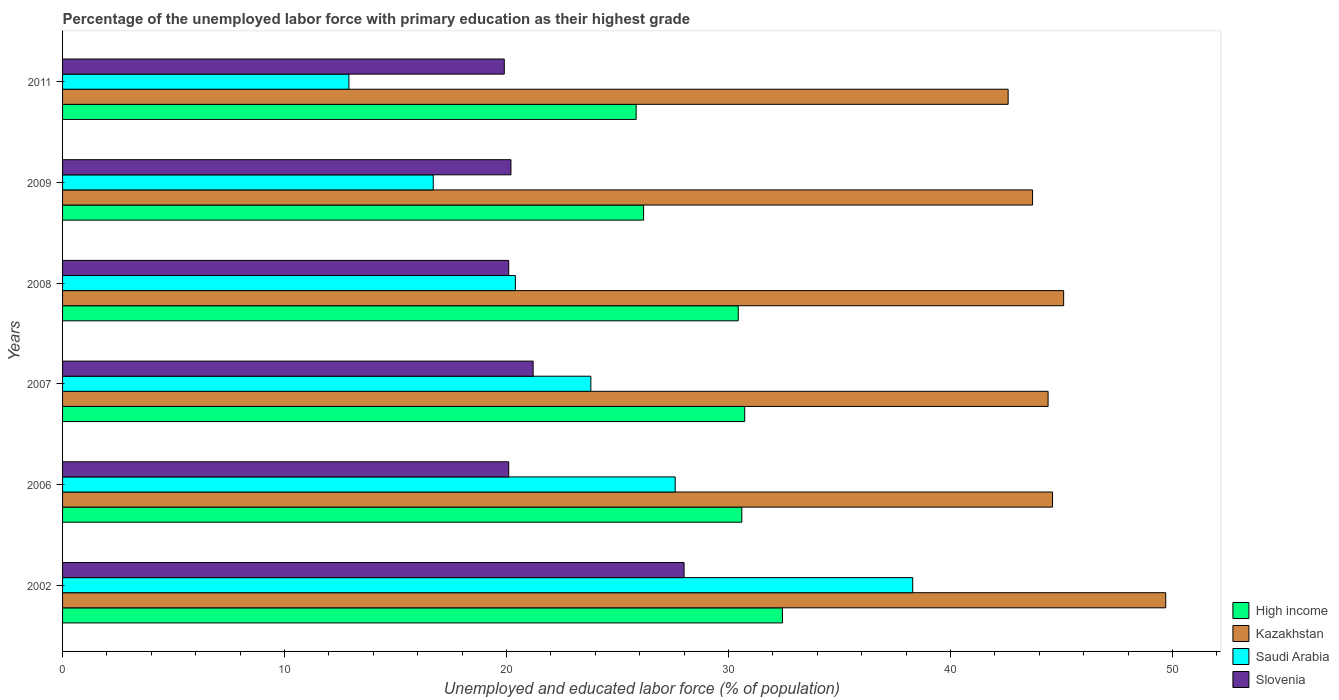How many bars are there on the 6th tick from the top?
Give a very brief answer. 4. How many bars are there on the 3rd tick from the bottom?
Provide a short and direct response. 4. In how many cases, is the number of bars for a given year not equal to the number of legend labels?
Offer a very short reply. 0. What is the percentage of the unemployed labor force with primary education in Kazakhstan in 2009?
Provide a short and direct response. 43.7. Across all years, what is the maximum percentage of the unemployed labor force with primary education in High income?
Offer a very short reply. 32.43. Across all years, what is the minimum percentage of the unemployed labor force with primary education in Slovenia?
Make the answer very short. 19.9. What is the total percentage of the unemployed labor force with primary education in Kazakhstan in the graph?
Your answer should be compact. 270.1. What is the difference between the percentage of the unemployed labor force with primary education in Slovenia in 2002 and that in 2006?
Your answer should be compact. 7.9. What is the difference between the percentage of the unemployed labor force with primary education in Saudi Arabia in 2006 and the percentage of the unemployed labor force with primary education in High income in 2008?
Offer a very short reply. -2.84. What is the average percentage of the unemployed labor force with primary education in High income per year?
Offer a terse response. 29.37. In the year 2007, what is the difference between the percentage of the unemployed labor force with primary education in Kazakhstan and percentage of the unemployed labor force with primary education in High income?
Give a very brief answer. 13.67. In how many years, is the percentage of the unemployed labor force with primary education in Slovenia greater than 36 %?
Keep it short and to the point. 0. What is the ratio of the percentage of the unemployed labor force with primary education in High income in 2002 to that in 2008?
Ensure brevity in your answer.  1.07. Is the percentage of the unemployed labor force with primary education in Kazakhstan in 2007 less than that in 2011?
Provide a short and direct response. No. Is the difference between the percentage of the unemployed labor force with primary education in Kazakhstan in 2002 and 2008 greater than the difference between the percentage of the unemployed labor force with primary education in High income in 2002 and 2008?
Provide a succinct answer. Yes. What is the difference between the highest and the second highest percentage of the unemployed labor force with primary education in Saudi Arabia?
Ensure brevity in your answer.  10.7. What is the difference between the highest and the lowest percentage of the unemployed labor force with primary education in High income?
Offer a very short reply. 6.59. What does the 2nd bar from the top in 2011 represents?
Make the answer very short. Saudi Arabia. What does the 1st bar from the bottom in 2011 represents?
Your response must be concise. High income. How many bars are there?
Ensure brevity in your answer.  24. Are all the bars in the graph horizontal?
Keep it short and to the point. Yes. How many years are there in the graph?
Your response must be concise. 6. Are the values on the major ticks of X-axis written in scientific E-notation?
Offer a very short reply. No. Does the graph contain any zero values?
Your answer should be very brief. No. Where does the legend appear in the graph?
Your response must be concise. Bottom right. How many legend labels are there?
Offer a very short reply. 4. What is the title of the graph?
Make the answer very short. Percentage of the unemployed labor force with primary education as their highest grade. Does "Aruba" appear as one of the legend labels in the graph?
Offer a very short reply. No. What is the label or title of the X-axis?
Make the answer very short. Unemployed and educated labor force (% of population). What is the Unemployed and educated labor force (% of population) in High income in 2002?
Ensure brevity in your answer.  32.43. What is the Unemployed and educated labor force (% of population) of Kazakhstan in 2002?
Make the answer very short. 49.7. What is the Unemployed and educated labor force (% of population) in Saudi Arabia in 2002?
Your answer should be compact. 38.3. What is the Unemployed and educated labor force (% of population) in Slovenia in 2002?
Offer a terse response. 28. What is the Unemployed and educated labor force (% of population) of High income in 2006?
Provide a succinct answer. 30.6. What is the Unemployed and educated labor force (% of population) of Kazakhstan in 2006?
Ensure brevity in your answer.  44.6. What is the Unemployed and educated labor force (% of population) in Saudi Arabia in 2006?
Provide a short and direct response. 27.6. What is the Unemployed and educated labor force (% of population) in Slovenia in 2006?
Keep it short and to the point. 20.1. What is the Unemployed and educated labor force (% of population) of High income in 2007?
Give a very brief answer. 30.73. What is the Unemployed and educated labor force (% of population) of Kazakhstan in 2007?
Offer a very short reply. 44.4. What is the Unemployed and educated labor force (% of population) of Saudi Arabia in 2007?
Your answer should be compact. 23.8. What is the Unemployed and educated labor force (% of population) of Slovenia in 2007?
Offer a very short reply. 21.2. What is the Unemployed and educated labor force (% of population) in High income in 2008?
Offer a very short reply. 30.44. What is the Unemployed and educated labor force (% of population) in Kazakhstan in 2008?
Keep it short and to the point. 45.1. What is the Unemployed and educated labor force (% of population) in Saudi Arabia in 2008?
Your answer should be compact. 20.4. What is the Unemployed and educated labor force (% of population) in Slovenia in 2008?
Your answer should be very brief. 20.1. What is the Unemployed and educated labor force (% of population) of High income in 2009?
Ensure brevity in your answer.  26.18. What is the Unemployed and educated labor force (% of population) of Kazakhstan in 2009?
Make the answer very short. 43.7. What is the Unemployed and educated labor force (% of population) of Saudi Arabia in 2009?
Give a very brief answer. 16.7. What is the Unemployed and educated labor force (% of population) of Slovenia in 2009?
Your answer should be compact. 20.2. What is the Unemployed and educated labor force (% of population) of High income in 2011?
Offer a very short reply. 25.84. What is the Unemployed and educated labor force (% of population) in Kazakhstan in 2011?
Ensure brevity in your answer.  42.6. What is the Unemployed and educated labor force (% of population) in Saudi Arabia in 2011?
Give a very brief answer. 12.9. What is the Unemployed and educated labor force (% of population) in Slovenia in 2011?
Your answer should be very brief. 19.9. Across all years, what is the maximum Unemployed and educated labor force (% of population) of High income?
Offer a terse response. 32.43. Across all years, what is the maximum Unemployed and educated labor force (% of population) in Kazakhstan?
Give a very brief answer. 49.7. Across all years, what is the maximum Unemployed and educated labor force (% of population) of Saudi Arabia?
Provide a succinct answer. 38.3. Across all years, what is the maximum Unemployed and educated labor force (% of population) in Slovenia?
Keep it short and to the point. 28. Across all years, what is the minimum Unemployed and educated labor force (% of population) in High income?
Offer a terse response. 25.84. Across all years, what is the minimum Unemployed and educated labor force (% of population) of Kazakhstan?
Offer a terse response. 42.6. Across all years, what is the minimum Unemployed and educated labor force (% of population) of Saudi Arabia?
Your response must be concise. 12.9. Across all years, what is the minimum Unemployed and educated labor force (% of population) of Slovenia?
Offer a terse response. 19.9. What is the total Unemployed and educated labor force (% of population) of High income in the graph?
Give a very brief answer. 176.22. What is the total Unemployed and educated labor force (% of population) of Kazakhstan in the graph?
Make the answer very short. 270.1. What is the total Unemployed and educated labor force (% of population) of Saudi Arabia in the graph?
Provide a succinct answer. 139.7. What is the total Unemployed and educated labor force (% of population) of Slovenia in the graph?
Provide a short and direct response. 129.5. What is the difference between the Unemployed and educated labor force (% of population) of High income in 2002 and that in 2006?
Offer a very short reply. 1.83. What is the difference between the Unemployed and educated labor force (% of population) in Kazakhstan in 2002 and that in 2006?
Offer a very short reply. 5.1. What is the difference between the Unemployed and educated labor force (% of population) in Slovenia in 2002 and that in 2006?
Your response must be concise. 7.9. What is the difference between the Unemployed and educated labor force (% of population) of Kazakhstan in 2002 and that in 2007?
Keep it short and to the point. 5.3. What is the difference between the Unemployed and educated labor force (% of population) in Slovenia in 2002 and that in 2007?
Provide a short and direct response. 6.8. What is the difference between the Unemployed and educated labor force (% of population) of High income in 2002 and that in 2008?
Keep it short and to the point. 1.99. What is the difference between the Unemployed and educated labor force (% of population) of High income in 2002 and that in 2009?
Offer a terse response. 6.25. What is the difference between the Unemployed and educated labor force (% of population) in Kazakhstan in 2002 and that in 2009?
Offer a very short reply. 6. What is the difference between the Unemployed and educated labor force (% of population) of Saudi Arabia in 2002 and that in 2009?
Ensure brevity in your answer.  21.6. What is the difference between the Unemployed and educated labor force (% of population) of Slovenia in 2002 and that in 2009?
Your answer should be very brief. 7.8. What is the difference between the Unemployed and educated labor force (% of population) in High income in 2002 and that in 2011?
Make the answer very short. 6.59. What is the difference between the Unemployed and educated labor force (% of population) in Saudi Arabia in 2002 and that in 2011?
Provide a short and direct response. 25.4. What is the difference between the Unemployed and educated labor force (% of population) of Slovenia in 2002 and that in 2011?
Offer a terse response. 8.1. What is the difference between the Unemployed and educated labor force (% of population) in High income in 2006 and that in 2007?
Your answer should be very brief. -0.13. What is the difference between the Unemployed and educated labor force (% of population) in Saudi Arabia in 2006 and that in 2007?
Offer a terse response. 3.8. What is the difference between the Unemployed and educated labor force (% of population) of Slovenia in 2006 and that in 2007?
Ensure brevity in your answer.  -1.1. What is the difference between the Unemployed and educated labor force (% of population) in High income in 2006 and that in 2008?
Your answer should be compact. 0.16. What is the difference between the Unemployed and educated labor force (% of population) of Kazakhstan in 2006 and that in 2008?
Offer a terse response. -0.5. What is the difference between the Unemployed and educated labor force (% of population) of Saudi Arabia in 2006 and that in 2008?
Your answer should be compact. 7.2. What is the difference between the Unemployed and educated labor force (% of population) in High income in 2006 and that in 2009?
Your answer should be very brief. 4.43. What is the difference between the Unemployed and educated labor force (% of population) in Kazakhstan in 2006 and that in 2009?
Give a very brief answer. 0.9. What is the difference between the Unemployed and educated labor force (% of population) in Saudi Arabia in 2006 and that in 2009?
Your response must be concise. 10.9. What is the difference between the Unemployed and educated labor force (% of population) in High income in 2006 and that in 2011?
Provide a short and direct response. 4.76. What is the difference between the Unemployed and educated labor force (% of population) in Kazakhstan in 2006 and that in 2011?
Give a very brief answer. 2. What is the difference between the Unemployed and educated labor force (% of population) in High income in 2007 and that in 2008?
Ensure brevity in your answer.  0.29. What is the difference between the Unemployed and educated labor force (% of population) in Saudi Arabia in 2007 and that in 2008?
Ensure brevity in your answer.  3.4. What is the difference between the Unemployed and educated labor force (% of population) in Slovenia in 2007 and that in 2008?
Your answer should be compact. 1.1. What is the difference between the Unemployed and educated labor force (% of population) in High income in 2007 and that in 2009?
Offer a very short reply. 4.55. What is the difference between the Unemployed and educated labor force (% of population) of Saudi Arabia in 2007 and that in 2009?
Your response must be concise. 7.1. What is the difference between the Unemployed and educated labor force (% of population) of High income in 2007 and that in 2011?
Your answer should be compact. 4.89. What is the difference between the Unemployed and educated labor force (% of population) in Saudi Arabia in 2007 and that in 2011?
Your answer should be compact. 10.9. What is the difference between the Unemployed and educated labor force (% of population) of High income in 2008 and that in 2009?
Offer a terse response. 4.26. What is the difference between the Unemployed and educated labor force (% of population) of Saudi Arabia in 2008 and that in 2009?
Your answer should be compact. 3.7. What is the difference between the Unemployed and educated labor force (% of population) of Slovenia in 2008 and that in 2009?
Ensure brevity in your answer.  -0.1. What is the difference between the Unemployed and educated labor force (% of population) in High income in 2008 and that in 2011?
Keep it short and to the point. 4.6. What is the difference between the Unemployed and educated labor force (% of population) in Saudi Arabia in 2008 and that in 2011?
Your response must be concise. 7.5. What is the difference between the Unemployed and educated labor force (% of population) in Slovenia in 2008 and that in 2011?
Your answer should be very brief. 0.2. What is the difference between the Unemployed and educated labor force (% of population) in High income in 2009 and that in 2011?
Your response must be concise. 0.33. What is the difference between the Unemployed and educated labor force (% of population) in Kazakhstan in 2009 and that in 2011?
Make the answer very short. 1.1. What is the difference between the Unemployed and educated labor force (% of population) of Saudi Arabia in 2009 and that in 2011?
Provide a short and direct response. 3.8. What is the difference between the Unemployed and educated labor force (% of population) of Slovenia in 2009 and that in 2011?
Offer a terse response. 0.3. What is the difference between the Unemployed and educated labor force (% of population) of High income in 2002 and the Unemployed and educated labor force (% of population) of Kazakhstan in 2006?
Offer a terse response. -12.17. What is the difference between the Unemployed and educated labor force (% of population) in High income in 2002 and the Unemployed and educated labor force (% of population) in Saudi Arabia in 2006?
Keep it short and to the point. 4.83. What is the difference between the Unemployed and educated labor force (% of population) of High income in 2002 and the Unemployed and educated labor force (% of population) of Slovenia in 2006?
Provide a succinct answer. 12.33. What is the difference between the Unemployed and educated labor force (% of population) in Kazakhstan in 2002 and the Unemployed and educated labor force (% of population) in Saudi Arabia in 2006?
Offer a very short reply. 22.1. What is the difference between the Unemployed and educated labor force (% of population) in Kazakhstan in 2002 and the Unemployed and educated labor force (% of population) in Slovenia in 2006?
Offer a very short reply. 29.6. What is the difference between the Unemployed and educated labor force (% of population) of Saudi Arabia in 2002 and the Unemployed and educated labor force (% of population) of Slovenia in 2006?
Your answer should be very brief. 18.2. What is the difference between the Unemployed and educated labor force (% of population) of High income in 2002 and the Unemployed and educated labor force (% of population) of Kazakhstan in 2007?
Keep it short and to the point. -11.97. What is the difference between the Unemployed and educated labor force (% of population) of High income in 2002 and the Unemployed and educated labor force (% of population) of Saudi Arabia in 2007?
Provide a succinct answer. 8.63. What is the difference between the Unemployed and educated labor force (% of population) in High income in 2002 and the Unemployed and educated labor force (% of population) in Slovenia in 2007?
Give a very brief answer. 11.23. What is the difference between the Unemployed and educated labor force (% of population) of Kazakhstan in 2002 and the Unemployed and educated labor force (% of population) of Saudi Arabia in 2007?
Provide a short and direct response. 25.9. What is the difference between the Unemployed and educated labor force (% of population) in Kazakhstan in 2002 and the Unemployed and educated labor force (% of population) in Slovenia in 2007?
Provide a short and direct response. 28.5. What is the difference between the Unemployed and educated labor force (% of population) of Saudi Arabia in 2002 and the Unemployed and educated labor force (% of population) of Slovenia in 2007?
Make the answer very short. 17.1. What is the difference between the Unemployed and educated labor force (% of population) in High income in 2002 and the Unemployed and educated labor force (% of population) in Kazakhstan in 2008?
Offer a terse response. -12.67. What is the difference between the Unemployed and educated labor force (% of population) in High income in 2002 and the Unemployed and educated labor force (% of population) in Saudi Arabia in 2008?
Offer a terse response. 12.03. What is the difference between the Unemployed and educated labor force (% of population) of High income in 2002 and the Unemployed and educated labor force (% of population) of Slovenia in 2008?
Provide a succinct answer. 12.33. What is the difference between the Unemployed and educated labor force (% of population) of Kazakhstan in 2002 and the Unemployed and educated labor force (% of population) of Saudi Arabia in 2008?
Give a very brief answer. 29.3. What is the difference between the Unemployed and educated labor force (% of population) in Kazakhstan in 2002 and the Unemployed and educated labor force (% of population) in Slovenia in 2008?
Provide a succinct answer. 29.6. What is the difference between the Unemployed and educated labor force (% of population) of Saudi Arabia in 2002 and the Unemployed and educated labor force (% of population) of Slovenia in 2008?
Offer a terse response. 18.2. What is the difference between the Unemployed and educated labor force (% of population) in High income in 2002 and the Unemployed and educated labor force (% of population) in Kazakhstan in 2009?
Your answer should be very brief. -11.27. What is the difference between the Unemployed and educated labor force (% of population) in High income in 2002 and the Unemployed and educated labor force (% of population) in Saudi Arabia in 2009?
Provide a succinct answer. 15.73. What is the difference between the Unemployed and educated labor force (% of population) of High income in 2002 and the Unemployed and educated labor force (% of population) of Slovenia in 2009?
Offer a very short reply. 12.23. What is the difference between the Unemployed and educated labor force (% of population) of Kazakhstan in 2002 and the Unemployed and educated labor force (% of population) of Slovenia in 2009?
Provide a succinct answer. 29.5. What is the difference between the Unemployed and educated labor force (% of population) in Saudi Arabia in 2002 and the Unemployed and educated labor force (% of population) in Slovenia in 2009?
Offer a very short reply. 18.1. What is the difference between the Unemployed and educated labor force (% of population) of High income in 2002 and the Unemployed and educated labor force (% of population) of Kazakhstan in 2011?
Keep it short and to the point. -10.17. What is the difference between the Unemployed and educated labor force (% of population) in High income in 2002 and the Unemployed and educated labor force (% of population) in Saudi Arabia in 2011?
Your response must be concise. 19.53. What is the difference between the Unemployed and educated labor force (% of population) in High income in 2002 and the Unemployed and educated labor force (% of population) in Slovenia in 2011?
Offer a very short reply. 12.53. What is the difference between the Unemployed and educated labor force (% of population) in Kazakhstan in 2002 and the Unemployed and educated labor force (% of population) in Saudi Arabia in 2011?
Make the answer very short. 36.8. What is the difference between the Unemployed and educated labor force (% of population) of Kazakhstan in 2002 and the Unemployed and educated labor force (% of population) of Slovenia in 2011?
Your response must be concise. 29.8. What is the difference between the Unemployed and educated labor force (% of population) in High income in 2006 and the Unemployed and educated labor force (% of population) in Kazakhstan in 2007?
Make the answer very short. -13.8. What is the difference between the Unemployed and educated labor force (% of population) in High income in 2006 and the Unemployed and educated labor force (% of population) in Saudi Arabia in 2007?
Keep it short and to the point. 6.8. What is the difference between the Unemployed and educated labor force (% of population) of High income in 2006 and the Unemployed and educated labor force (% of population) of Slovenia in 2007?
Your answer should be compact. 9.4. What is the difference between the Unemployed and educated labor force (% of population) in Kazakhstan in 2006 and the Unemployed and educated labor force (% of population) in Saudi Arabia in 2007?
Provide a short and direct response. 20.8. What is the difference between the Unemployed and educated labor force (% of population) of Kazakhstan in 2006 and the Unemployed and educated labor force (% of population) of Slovenia in 2007?
Provide a succinct answer. 23.4. What is the difference between the Unemployed and educated labor force (% of population) of High income in 2006 and the Unemployed and educated labor force (% of population) of Kazakhstan in 2008?
Provide a succinct answer. -14.5. What is the difference between the Unemployed and educated labor force (% of population) of High income in 2006 and the Unemployed and educated labor force (% of population) of Saudi Arabia in 2008?
Your response must be concise. 10.2. What is the difference between the Unemployed and educated labor force (% of population) in High income in 2006 and the Unemployed and educated labor force (% of population) in Slovenia in 2008?
Ensure brevity in your answer.  10.5. What is the difference between the Unemployed and educated labor force (% of population) in Kazakhstan in 2006 and the Unemployed and educated labor force (% of population) in Saudi Arabia in 2008?
Your answer should be very brief. 24.2. What is the difference between the Unemployed and educated labor force (% of population) of Saudi Arabia in 2006 and the Unemployed and educated labor force (% of population) of Slovenia in 2008?
Keep it short and to the point. 7.5. What is the difference between the Unemployed and educated labor force (% of population) in High income in 2006 and the Unemployed and educated labor force (% of population) in Kazakhstan in 2009?
Offer a very short reply. -13.1. What is the difference between the Unemployed and educated labor force (% of population) of High income in 2006 and the Unemployed and educated labor force (% of population) of Saudi Arabia in 2009?
Offer a very short reply. 13.9. What is the difference between the Unemployed and educated labor force (% of population) in High income in 2006 and the Unemployed and educated labor force (% of population) in Slovenia in 2009?
Provide a succinct answer. 10.4. What is the difference between the Unemployed and educated labor force (% of population) of Kazakhstan in 2006 and the Unemployed and educated labor force (% of population) of Saudi Arabia in 2009?
Ensure brevity in your answer.  27.9. What is the difference between the Unemployed and educated labor force (% of population) of Kazakhstan in 2006 and the Unemployed and educated labor force (% of population) of Slovenia in 2009?
Give a very brief answer. 24.4. What is the difference between the Unemployed and educated labor force (% of population) of Saudi Arabia in 2006 and the Unemployed and educated labor force (% of population) of Slovenia in 2009?
Your response must be concise. 7.4. What is the difference between the Unemployed and educated labor force (% of population) in High income in 2006 and the Unemployed and educated labor force (% of population) in Kazakhstan in 2011?
Offer a very short reply. -12. What is the difference between the Unemployed and educated labor force (% of population) of High income in 2006 and the Unemployed and educated labor force (% of population) of Saudi Arabia in 2011?
Offer a terse response. 17.7. What is the difference between the Unemployed and educated labor force (% of population) in High income in 2006 and the Unemployed and educated labor force (% of population) in Slovenia in 2011?
Offer a very short reply. 10.7. What is the difference between the Unemployed and educated labor force (% of population) in Kazakhstan in 2006 and the Unemployed and educated labor force (% of population) in Saudi Arabia in 2011?
Provide a short and direct response. 31.7. What is the difference between the Unemployed and educated labor force (% of population) in Kazakhstan in 2006 and the Unemployed and educated labor force (% of population) in Slovenia in 2011?
Offer a terse response. 24.7. What is the difference between the Unemployed and educated labor force (% of population) in Saudi Arabia in 2006 and the Unemployed and educated labor force (% of population) in Slovenia in 2011?
Keep it short and to the point. 7.7. What is the difference between the Unemployed and educated labor force (% of population) in High income in 2007 and the Unemployed and educated labor force (% of population) in Kazakhstan in 2008?
Give a very brief answer. -14.37. What is the difference between the Unemployed and educated labor force (% of population) of High income in 2007 and the Unemployed and educated labor force (% of population) of Saudi Arabia in 2008?
Offer a terse response. 10.33. What is the difference between the Unemployed and educated labor force (% of population) in High income in 2007 and the Unemployed and educated labor force (% of population) in Slovenia in 2008?
Keep it short and to the point. 10.63. What is the difference between the Unemployed and educated labor force (% of population) in Kazakhstan in 2007 and the Unemployed and educated labor force (% of population) in Slovenia in 2008?
Provide a succinct answer. 24.3. What is the difference between the Unemployed and educated labor force (% of population) of Saudi Arabia in 2007 and the Unemployed and educated labor force (% of population) of Slovenia in 2008?
Your response must be concise. 3.7. What is the difference between the Unemployed and educated labor force (% of population) in High income in 2007 and the Unemployed and educated labor force (% of population) in Kazakhstan in 2009?
Keep it short and to the point. -12.97. What is the difference between the Unemployed and educated labor force (% of population) of High income in 2007 and the Unemployed and educated labor force (% of population) of Saudi Arabia in 2009?
Offer a very short reply. 14.03. What is the difference between the Unemployed and educated labor force (% of population) of High income in 2007 and the Unemployed and educated labor force (% of population) of Slovenia in 2009?
Offer a terse response. 10.53. What is the difference between the Unemployed and educated labor force (% of population) of Kazakhstan in 2007 and the Unemployed and educated labor force (% of population) of Saudi Arabia in 2009?
Give a very brief answer. 27.7. What is the difference between the Unemployed and educated labor force (% of population) of Kazakhstan in 2007 and the Unemployed and educated labor force (% of population) of Slovenia in 2009?
Provide a succinct answer. 24.2. What is the difference between the Unemployed and educated labor force (% of population) in Saudi Arabia in 2007 and the Unemployed and educated labor force (% of population) in Slovenia in 2009?
Offer a very short reply. 3.6. What is the difference between the Unemployed and educated labor force (% of population) in High income in 2007 and the Unemployed and educated labor force (% of population) in Kazakhstan in 2011?
Keep it short and to the point. -11.87. What is the difference between the Unemployed and educated labor force (% of population) of High income in 2007 and the Unemployed and educated labor force (% of population) of Saudi Arabia in 2011?
Ensure brevity in your answer.  17.83. What is the difference between the Unemployed and educated labor force (% of population) of High income in 2007 and the Unemployed and educated labor force (% of population) of Slovenia in 2011?
Your answer should be compact. 10.83. What is the difference between the Unemployed and educated labor force (% of population) in Kazakhstan in 2007 and the Unemployed and educated labor force (% of population) in Saudi Arabia in 2011?
Your response must be concise. 31.5. What is the difference between the Unemployed and educated labor force (% of population) in High income in 2008 and the Unemployed and educated labor force (% of population) in Kazakhstan in 2009?
Your answer should be very brief. -13.26. What is the difference between the Unemployed and educated labor force (% of population) in High income in 2008 and the Unemployed and educated labor force (% of population) in Saudi Arabia in 2009?
Your answer should be compact. 13.74. What is the difference between the Unemployed and educated labor force (% of population) of High income in 2008 and the Unemployed and educated labor force (% of population) of Slovenia in 2009?
Your response must be concise. 10.24. What is the difference between the Unemployed and educated labor force (% of population) of Kazakhstan in 2008 and the Unemployed and educated labor force (% of population) of Saudi Arabia in 2009?
Ensure brevity in your answer.  28.4. What is the difference between the Unemployed and educated labor force (% of population) in Kazakhstan in 2008 and the Unemployed and educated labor force (% of population) in Slovenia in 2009?
Provide a succinct answer. 24.9. What is the difference between the Unemployed and educated labor force (% of population) of High income in 2008 and the Unemployed and educated labor force (% of population) of Kazakhstan in 2011?
Provide a succinct answer. -12.16. What is the difference between the Unemployed and educated labor force (% of population) of High income in 2008 and the Unemployed and educated labor force (% of population) of Saudi Arabia in 2011?
Provide a short and direct response. 17.54. What is the difference between the Unemployed and educated labor force (% of population) of High income in 2008 and the Unemployed and educated labor force (% of population) of Slovenia in 2011?
Your answer should be very brief. 10.54. What is the difference between the Unemployed and educated labor force (% of population) in Kazakhstan in 2008 and the Unemployed and educated labor force (% of population) in Saudi Arabia in 2011?
Provide a succinct answer. 32.2. What is the difference between the Unemployed and educated labor force (% of population) in Kazakhstan in 2008 and the Unemployed and educated labor force (% of population) in Slovenia in 2011?
Provide a short and direct response. 25.2. What is the difference between the Unemployed and educated labor force (% of population) in High income in 2009 and the Unemployed and educated labor force (% of population) in Kazakhstan in 2011?
Your answer should be compact. -16.42. What is the difference between the Unemployed and educated labor force (% of population) of High income in 2009 and the Unemployed and educated labor force (% of population) of Saudi Arabia in 2011?
Provide a succinct answer. 13.28. What is the difference between the Unemployed and educated labor force (% of population) in High income in 2009 and the Unemployed and educated labor force (% of population) in Slovenia in 2011?
Ensure brevity in your answer.  6.28. What is the difference between the Unemployed and educated labor force (% of population) of Kazakhstan in 2009 and the Unemployed and educated labor force (% of population) of Saudi Arabia in 2011?
Your answer should be very brief. 30.8. What is the difference between the Unemployed and educated labor force (% of population) of Kazakhstan in 2009 and the Unemployed and educated labor force (% of population) of Slovenia in 2011?
Your answer should be very brief. 23.8. What is the average Unemployed and educated labor force (% of population) of High income per year?
Your response must be concise. 29.37. What is the average Unemployed and educated labor force (% of population) of Kazakhstan per year?
Your answer should be compact. 45.02. What is the average Unemployed and educated labor force (% of population) of Saudi Arabia per year?
Your answer should be compact. 23.28. What is the average Unemployed and educated labor force (% of population) of Slovenia per year?
Make the answer very short. 21.58. In the year 2002, what is the difference between the Unemployed and educated labor force (% of population) in High income and Unemployed and educated labor force (% of population) in Kazakhstan?
Keep it short and to the point. -17.27. In the year 2002, what is the difference between the Unemployed and educated labor force (% of population) in High income and Unemployed and educated labor force (% of population) in Saudi Arabia?
Provide a short and direct response. -5.87. In the year 2002, what is the difference between the Unemployed and educated labor force (% of population) of High income and Unemployed and educated labor force (% of population) of Slovenia?
Make the answer very short. 4.43. In the year 2002, what is the difference between the Unemployed and educated labor force (% of population) in Kazakhstan and Unemployed and educated labor force (% of population) in Saudi Arabia?
Provide a short and direct response. 11.4. In the year 2002, what is the difference between the Unemployed and educated labor force (% of population) in Kazakhstan and Unemployed and educated labor force (% of population) in Slovenia?
Give a very brief answer. 21.7. In the year 2006, what is the difference between the Unemployed and educated labor force (% of population) of High income and Unemployed and educated labor force (% of population) of Kazakhstan?
Keep it short and to the point. -14. In the year 2006, what is the difference between the Unemployed and educated labor force (% of population) in High income and Unemployed and educated labor force (% of population) in Saudi Arabia?
Provide a short and direct response. 3. In the year 2006, what is the difference between the Unemployed and educated labor force (% of population) in High income and Unemployed and educated labor force (% of population) in Slovenia?
Give a very brief answer. 10.5. In the year 2006, what is the difference between the Unemployed and educated labor force (% of population) of Kazakhstan and Unemployed and educated labor force (% of population) of Saudi Arabia?
Your answer should be very brief. 17. In the year 2006, what is the difference between the Unemployed and educated labor force (% of population) in Kazakhstan and Unemployed and educated labor force (% of population) in Slovenia?
Your response must be concise. 24.5. In the year 2006, what is the difference between the Unemployed and educated labor force (% of population) in Saudi Arabia and Unemployed and educated labor force (% of population) in Slovenia?
Make the answer very short. 7.5. In the year 2007, what is the difference between the Unemployed and educated labor force (% of population) of High income and Unemployed and educated labor force (% of population) of Kazakhstan?
Ensure brevity in your answer.  -13.67. In the year 2007, what is the difference between the Unemployed and educated labor force (% of population) in High income and Unemployed and educated labor force (% of population) in Saudi Arabia?
Give a very brief answer. 6.93. In the year 2007, what is the difference between the Unemployed and educated labor force (% of population) of High income and Unemployed and educated labor force (% of population) of Slovenia?
Provide a short and direct response. 9.53. In the year 2007, what is the difference between the Unemployed and educated labor force (% of population) in Kazakhstan and Unemployed and educated labor force (% of population) in Saudi Arabia?
Your answer should be very brief. 20.6. In the year 2007, what is the difference between the Unemployed and educated labor force (% of population) in Kazakhstan and Unemployed and educated labor force (% of population) in Slovenia?
Your answer should be very brief. 23.2. In the year 2008, what is the difference between the Unemployed and educated labor force (% of population) in High income and Unemployed and educated labor force (% of population) in Kazakhstan?
Give a very brief answer. -14.66. In the year 2008, what is the difference between the Unemployed and educated labor force (% of population) in High income and Unemployed and educated labor force (% of population) in Saudi Arabia?
Offer a very short reply. 10.04. In the year 2008, what is the difference between the Unemployed and educated labor force (% of population) of High income and Unemployed and educated labor force (% of population) of Slovenia?
Keep it short and to the point. 10.34. In the year 2008, what is the difference between the Unemployed and educated labor force (% of population) in Kazakhstan and Unemployed and educated labor force (% of population) in Saudi Arabia?
Offer a terse response. 24.7. In the year 2008, what is the difference between the Unemployed and educated labor force (% of population) in Kazakhstan and Unemployed and educated labor force (% of population) in Slovenia?
Keep it short and to the point. 25. In the year 2008, what is the difference between the Unemployed and educated labor force (% of population) in Saudi Arabia and Unemployed and educated labor force (% of population) in Slovenia?
Give a very brief answer. 0.3. In the year 2009, what is the difference between the Unemployed and educated labor force (% of population) in High income and Unemployed and educated labor force (% of population) in Kazakhstan?
Your response must be concise. -17.52. In the year 2009, what is the difference between the Unemployed and educated labor force (% of population) of High income and Unemployed and educated labor force (% of population) of Saudi Arabia?
Provide a succinct answer. 9.48. In the year 2009, what is the difference between the Unemployed and educated labor force (% of population) in High income and Unemployed and educated labor force (% of population) in Slovenia?
Keep it short and to the point. 5.98. In the year 2009, what is the difference between the Unemployed and educated labor force (% of population) in Saudi Arabia and Unemployed and educated labor force (% of population) in Slovenia?
Offer a very short reply. -3.5. In the year 2011, what is the difference between the Unemployed and educated labor force (% of population) of High income and Unemployed and educated labor force (% of population) of Kazakhstan?
Your response must be concise. -16.76. In the year 2011, what is the difference between the Unemployed and educated labor force (% of population) of High income and Unemployed and educated labor force (% of population) of Saudi Arabia?
Keep it short and to the point. 12.94. In the year 2011, what is the difference between the Unemployed and educated labor force (% of population) of High income and Unemployed and educated labor force (% of population) of Slovenia?
Offer a very short reply. 5.94. In the year 2011, what is the difference between the Unemployed and educated labor force (% of population) of Kazakhstan and Unemployed and educated labor force (% of population) of Saudi Arabia?
Your answer should be very brief. 29.7. In the year 2011, what is the difference between the Unemployed and educated labor force (% of population) in Kazakhstan and Unemployed and educated labor force (% of population) in Slovenia?
Provide a short and direct response. 22.7. In the year 2011, what is the difference between the Unemployed and educated labor force (% of population) of Saudi Arabia and Unemployed and educated labor force (% of population) of Slovenia?
Your answer should be compact. -7. What is the ratio of the Unemployed and educated labor force (% of population) in High income in 2002 to that in 2006?
Ensure brevity in your answer.  1.06. What is the ratio of the Unemployed and educated labor force (% of population) of Kazakhstan in 2002 to that in 2006?
Provide a short and direct response. 1.11. What is the ratio of the Unemployed and educated labor force (% of population) in Saudi Arabia in 2002 to that in 2006?
Provide a short and direct response. 1.39. What is the ratio of the Unemployed and educated labor force (% of population) of Slovenia in 2002 to that in 2006?
Your answer should be compact. 1.39. What is the ratio of the Unemployed and educated labor force (% of population) of High income in 2002 to that in 2007?
Ensure brevity in your answer.  1.06. What is the ratio of the Unemployed and educated labor force (% of population) of Kazakhstan in 2002 to that in 2007?
Provide a short and direct response. 1.12. What is the ratio of the Unemployed and educated labor force (% of population) in Saudi Arabia in 2002 to that in 2007?
Your response must be concise. 1.61. What is the ratio of the Unemployed and educated labor force (% of population) of Slovenia in 2002 to that in 2007?
Keep it short and to the point. 1.32. What is the ratio of the Unemployed and educated labor force (% of population) in High income in 2002 to that in 2008?
Provide a succinct answer. 1.07. What is the ratio of the Unemployed and educated labor force (% of population) of Kazakhstan in 2002 to that in 2008?
Provide a short and direct response. 1.1. What is the ratio of the Unemployed and educated labor force (% of population) in Saudi Arabia in 2002 to that in 2008?
Provide a short and direct response. 1.88. What is the ratio of the Unemployed and educated labor force (% of population) of Slovenia in 2002 to that in 2008?
Keep it short and to the point. 1.39. What is the ratio of the Unemployed and educated labor force (% of population) in High income in 2002 to that in 2009?
Offer a very short reply. 1.24. What is the ratio of the Unemployed and educated labor force (% of population) in Kazakhstan in 2002 to that in 2009?
Your answer should be compact. 1.14. What is the ratio of the Unemployed and educated labor force (% of population) of Saudi Arabia in 2002 to that in 2009?
Provide a short and direct response. 2.29. What is the ratio of the Unemployed and educated labor force (% of population) in Slovenia in 2002 to that in 2009?
Your answer should be very brief. 1.39. What is the ratio of the Unemployed and educated labor force (% of population) of High income in 2002 to that in 2011?
Your response must be concise. 1.25. What is the ratio of the Unemployed and educated labor force (% of population) in Kazakhstan in 2002 to that in 2011?
Provide a succinct answer. 1.17. What is the ratio of the Unemployed and educated labor force (% of population) of Saudi Arabia in 2002 to that in 2011?
Provide a short and direct response. 2.97. What is the ratio of the Unemployed and educated labor force (% of population) of Slovenia in 2002 to that in 2011?
Ensure brevity in your answer.  1.41. What is the ratio of the Unemployed and educated labor force (% of population) of Kazakhstan in 2006 to that in 2007?
Provide a short and direct response. 1. What is the ratio of the Unemployed and educated labor force (% of population) in Saudi Arabia in 2006 to that in 2007?
Your answer should be very brief. 1.16. What is the ratio of the Unemployed and educated labor force (% of population) in Slovenia in 2006 to that in 2007?
Provide a short and direct response. 0.95. What is the ratio of the Unemployed and educated labor force (% of population) of High income in 2006 to that in 2008?
Your answer should be very brief. 1.01. What is the ratio of the Unemployed and educated labor force (% of population) of Kazakhstan in 2006 to that in 2008?
Make the answer very short. 0.99. What is the ratio of the Unemployed and educated labor force (% of population) of Saudi Arabia in 2006 to that in 2008?
Keep it short and to the point. 1.35. What is the ratio of the Unemployed and educated labor force (% of population) in High income in 2006 to that in 2009?
Offer a very short reply. 1.17. What is the ratio of the Unemployed and educated labor force (% of population) in Kazakhstan in 2006 to that in 2009?
Offer a terse response. 1.02. What is the ratio of the Unemployed and educated labor force (% of population) of Saudi Arabia in 2006 to that in 2009?
Ensure brevity in your answer.  1.65. What is the ratio of the Unemployed and educated labor force (% of population) in Slovenia in 2006 to that in 2009?
Your answer should be very brief. 0.99. What is the ratio of the Unemployed and educated labor force (% of population) in High income in 2006 to that in 2011?
Your answer should be very brief. 1.18. What is the ratio of the Unemployed and educated labor force (% of population) in Kazakhstan in 2006 to that in 2011?
Give a very brief answer. 1.05. What is the ratio of the Unemployed and educated labor force (% of population) of Saudi Arabia in 2006 to that in 2011?
Make the answer very short. 2.14. What is the ratio of the Unemployed and educated labor force (% of population) of Slovenia in 2006 to that in 2011?
Offer a very short reply. 1.01. What is the ratio of the Unemployed and educated labor force (% of population) of High income in 2007 to that in 2008?
Make the answer very short. 1.01. What is the ratio of the Unemployed and educated labor force (% of population) of Kazakhstan in 2007 to that in 2008?
Make the answer very short. 0.98. What is the ratio of the Unemployed and educated labor force (% of population) of Slovenia in 2007 to that in 2008?
Your response must be concise. 1.05. What is the ratio of the Unemployed and educated labor force (% of population) of High income in 2007 to that in 2009?
Offer a terse response. 1.17. What is the ratio of the Unemployed and educated labor force (% of population) of Saudi Arabia in 2007 to that in 2009?
Your answer should be very brief. 1.43. What is the ratio of the Unemployed and educated labor force (% of population) in Slovenia in 2007 to that in 2009?
Offer a very short reply. 1.05. What is the ratio of the Unemployed and educated labor force (% of population) of High income in 2007 to that in 2011?
Make the answer very short. 1.19. What is the ratio of the Unemployed and educated labor force (% of population) in Kazakhstan in 2007 to that in 2011?
Give a very brief answer. 1.04. What is the ratio of the Unemployed and educated labor force (% of population) in Saudi Arabia in 2007 to that in 2011?
Your answer should be compact. 1.84. What is the ratio of the Unemployed and educated labor force (% of population) in Slovenia in 2007 to that in 2011?
Keep it short and to the point. 1.07. What is the ratio of the Unemployed and educated labor force (% of population) of High income in 2008 to that in 2009?
Provide a succinct answer. 1.16. What is the ratio of the Unemployed and educated labor force (% of population) of Kazakhstan in 2008 to that in 2009?
Give a very brief answer. 1.03. What is the ratio of the Unemployed and educated labor force (% of population) of Saudi Arabia in 2008 to that in 2009?
Offer a very short reply. 1.22. What is the ratio of the Unemployed and educated labor force (% of population) of Slovenia in 2008 to that in 2009?
Ensure brevity in your answer.  0.99. What is the ratio of the Unemployed and educated labor force (% of population) of High income in 2008 to that in 2011?
Provide a short and direct response. 1.18. What is the ratio of the Unemployed and educated labor force (% of population) in Kazakhstan in 2008 to that in 2011?
Your answer should be very brief. 1.06. What is the ratio of the Unemployed and educated labor force (% of population) of Saudi Arabia in 2008 to that in 2011?
Provide a short and direct response. 1.58. What is the ratio of the Unemployed and educated labor force (% of population) of High income in 2009 to that in 2011?
Give a very brief answer. 1.01. What is the ratio of the Unemployed and educated labor force (% of population) in Kazakhstan in 2009 to that in 2011?
Your response must be concise. 1.03. What is the ratio of the Unemployed and educated labor force (% of population) of Saudi Arabia in 2009 to that in 2011?
Your answer should be very brief. 1.29. What is the ratio of the Unemployed and educated labor force (% of population) of Slovenia in 2009 to that in 2011?
Offer a terse response. 1.02. What is the difference between the highest and the second highest Unemployed and educated labor force (% of population) of Kazakhstan?
Your response must be concise. 4.6. What is the difference between the highest and the second highest Unemployed and educated labor force (% of population) of Saudi Arabia?
Your response must be concise. 10.7. What is the difference between the highest and the lowest Unemployed and educated labor force (% of population) of High income?
Give a very brief answer. 6.59. What is the difference between the highest and the lowest Unemployed and educated labor force (% of population) in Kazakhstan?
Your answer should be very brief. 7.1. What is the difference between the highest and the lowest Unemployed and educated labor force (% of population) of Saudi Arabia?
Your answer should be very brief. 25.4. 